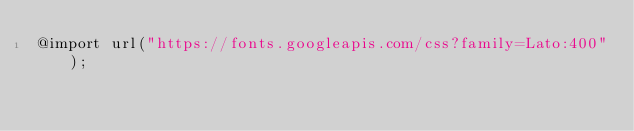<code> <loc_0><loc_0><loc_500><loc_500><_CSS_>@import url("https://fonts.googleapis.com/css?family=Lato:400");</code> 